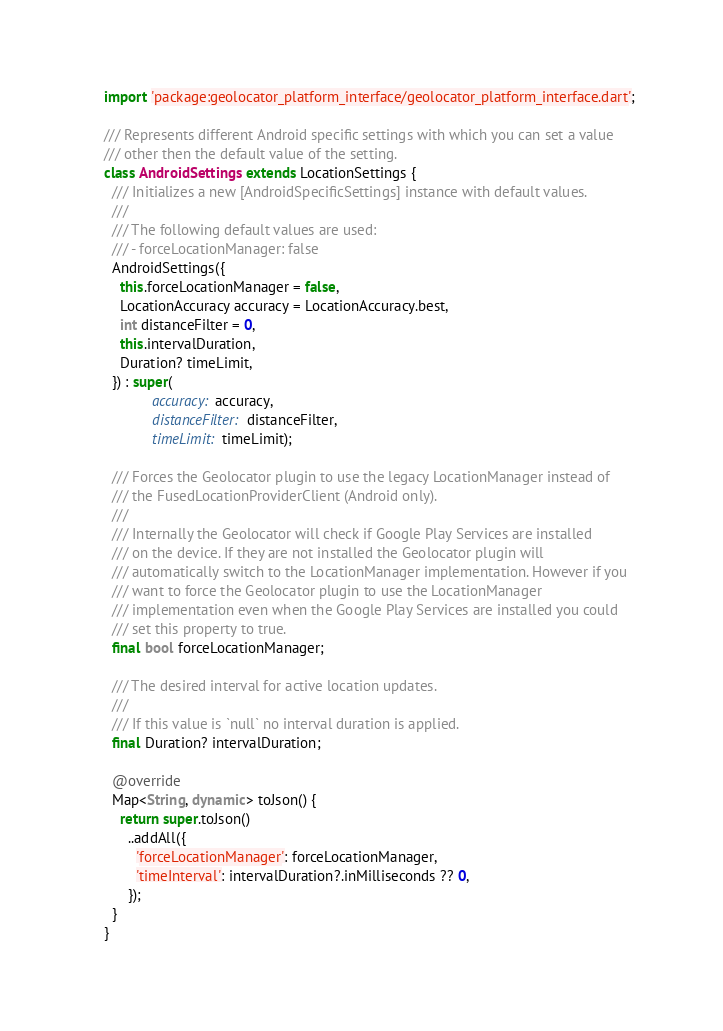Convert code to text. <code><loc_0><loc_0><loc_500><loc_500><_Dart_>import 'package:geolocator_platform_interface/geolocator_platform_interface.dart';

/// Represents different Android specific settings with which you can set a value
/// other then the default value of the setting.
class AndroidSettings extends LocationSettings {
  /// Initializes a new [AndroidSpecificSettings] instance with default values.
  ///
  /// The following default values are used:
  /// - forceLocationManager: false
  AndroidSettings({
    this.forceLocationManager = false,
    LocationAccuracy accuracy = LocationAccuracy.best,
    int distanceFilter = 0,
    this.intervalDuration,
    Duration? timeLimit,
  }) : super(
            accuracy: accuracy,
            distanceFilter: distanceFilter,
            timeLimit: timeLimit);

  /// Forces the Geolocator plugin to use the legacy LocationManager instead of
  /// the FusedLocationProviderClient (Android only).
  ///
  /// Internally the Geolocator will check if Google Play Services are installed
  /// on the device. If they are not installed the Geolocator plugin will
  /// automatically switch to the LocationManager implementation. However if you
  /// want to force the Geolocator plugin to use the LocationManager
  /// implementation even when the Google Play Services are installed you could
  /// set this property to true.
  final bool forceLocationManager;

  /// The desired interval for active location updates.
  ///
  /// If this value is `null` no interval duration is applied.
  final Duration? intervalDuration;

  @override
  Map<String, dynamic> toJson() {
    return super.toJson()
      ..addAll({
        'forceLocationManager': forceLocationManager,
        'timeInterval': intervalDuration?.inMilliseconds ?? 0,
      });
  }
}
</code> 